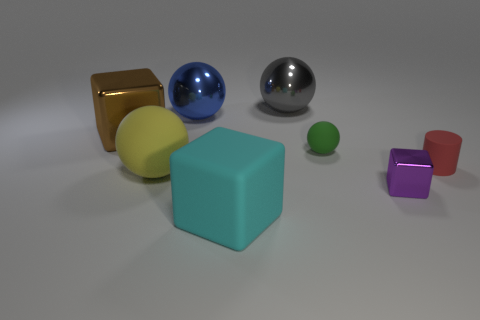Add 2 large blue shiny objects. How many objects exist? 10 Subtract all cylinders. How many objects are left? 7 Subtract 0 purple cylinders. How many objects are left? 8 Subtract all tiny gray metallic cylinders. Subtract all cyan cubes. How many objects are left? 7 Add 5 big blocks. How many big blocks are left? 7 Add 4 small things. How many small things exist? 7 